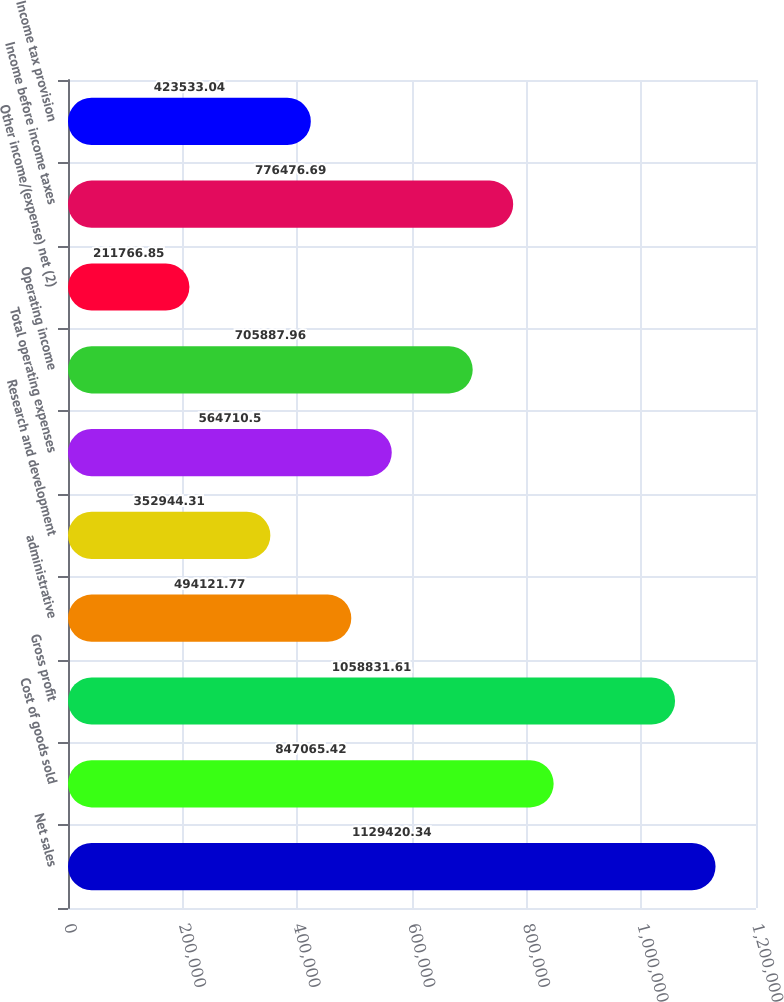<chart> <loc_0><loc_0><loc_500><loc_500><bar_chart><fcel>Net sales<fcel>Cost of goods sold<fcel>Gross profit<fcel>administrative<fcel>Research and development<fcel>Total operating expenses<fcel>Operating income<fcel>Other income/(expense) net (2)<fcel>Income before income taxes<fcel>Income tax provision<nl><fcel>1.12942e+06<fcel>847065<fcel>1.05883e+06<fcel>494122<fcel>352944<fcel>564710<fcel>705888<fcel>211767<fcel>776477<fcel>423533<nl></chart> 